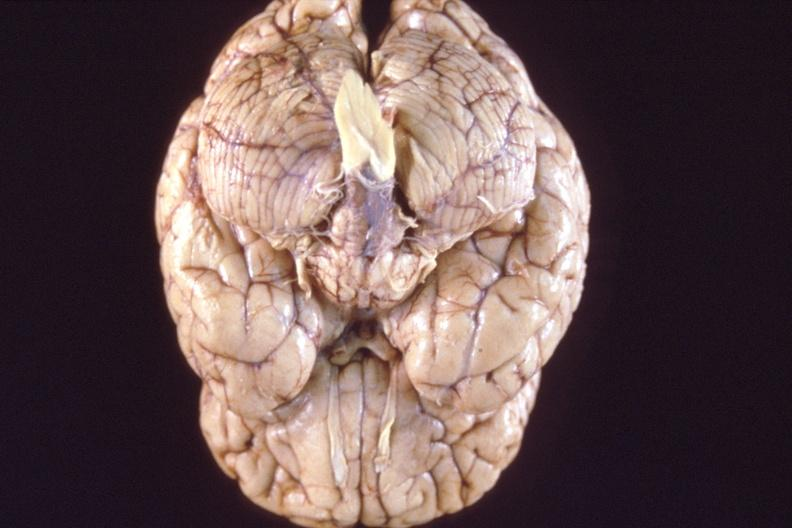s nervous present?
Answer the question using a single word or phrase. Yes 